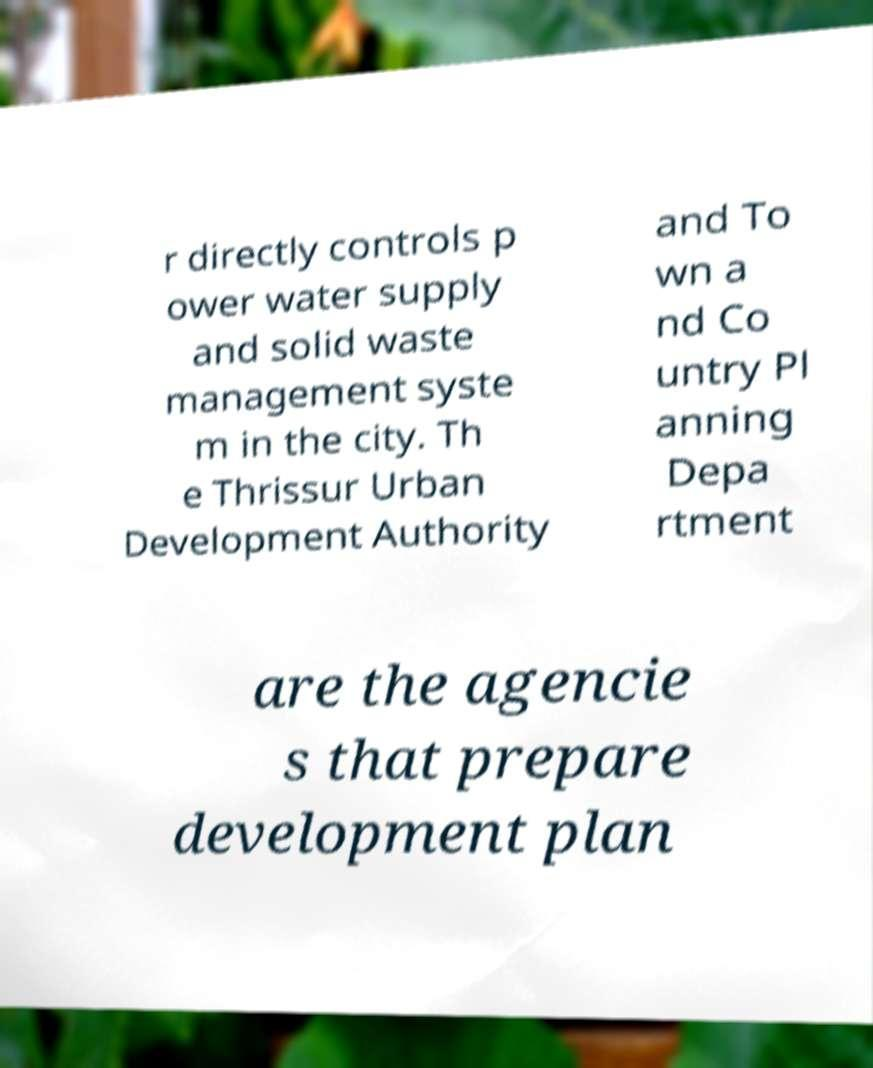Can you read and provide the text displayed in the image?This photo seems to have some interesting text. Can you extract and type it out for me? r directly controls p ower water supply and solid waste management syste m in the city. Th e Thrissur Urban Development Authority and To wn a nd Co untry Pl anning Depa rtment are the agencie s that prepare development plan 